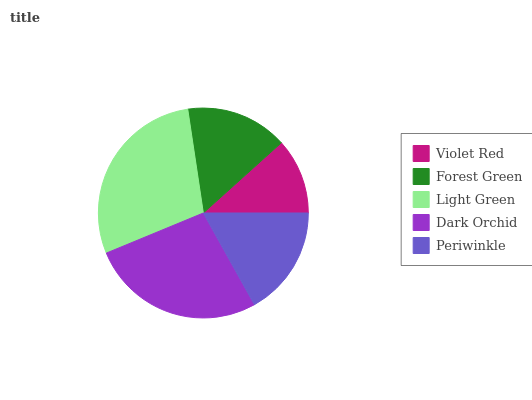Is Violet Red the minimum?
Answer yes or no. Yes. Is Light Green the maximum?
Answer yes or no. Yes. Is Forest Green the minimum?
Answer yes or no. No. Is Forest Green the maximum?
Answer yes or no. No. Is Forest Green greater than Violet Red?
Answer yes or no. Yes. Is Violet Red less than Forest Green?
Answer yes or no. Yes. Is Violet Red greater than Forest Green?
Answer yes or no. No. Is Forest Green less than Violet Red?
Answer yes or no. No. Is Periwinkle the high median?
Answer yes or no. Yes. Is Periwinkle the low median?
Answer yes or no. Yes. Is Forest Green the high median?
Answer yes or no. No. Is Light Green the low median?
Answer yes or no. No. 